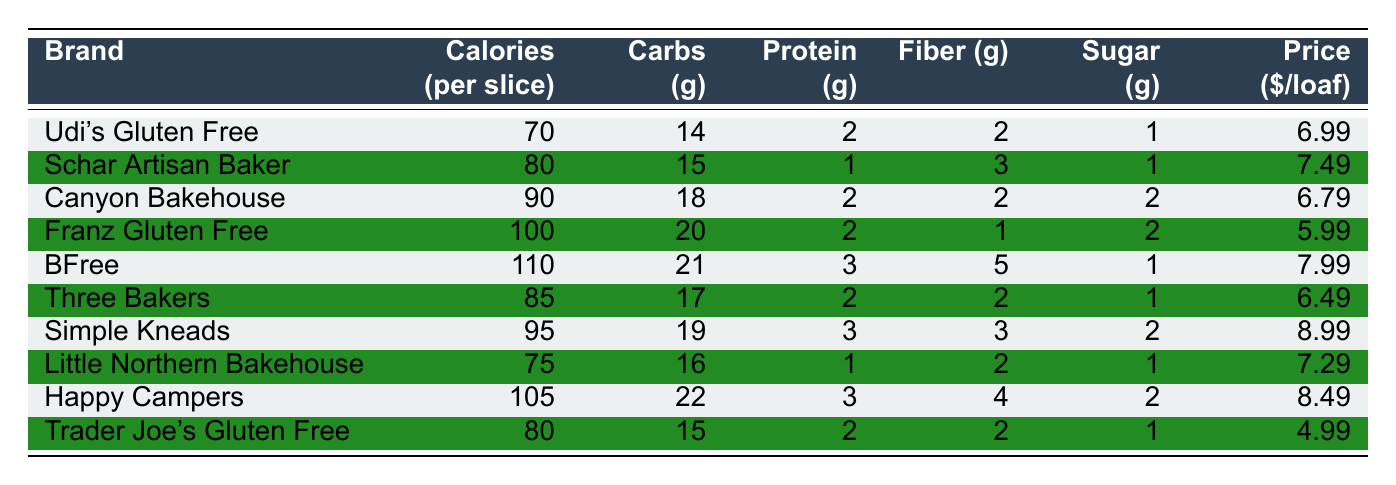What brand has the lowest calories per slice? By checking the "Calories (per slice)" column, Udi's Gluten Free has the lowest at 70 calories.
Answer: Udi's Gluten Free Which brand has the highest sugar content? Looking at the "Sugar (g)" column, Happy Campers has the highest with 2 grams of sugar.
Answer: Happy Campers What is the average price of the gluten-free bread brands listed? To find the average price, sum all prices ($6.99 + $7.49 + $6.79 + $5.99 + $7.99 + $6.49 + $8.99 + $7.29 + $8.49 + $4.99 = $69.49) and divide by 10, which gives $6.949.
Answer: $6.95 Is there a brand that has more protein than Canyon Bakehouse? Canyon Bakehouse has 2 grams of protein. BFree and Simple Kneads have 3 grams of protein, which is more than Canyon Bakehouse.
Answer: Yes Which brand's price is the lowest, and how much is it? Trader Joe's Gluten Free has the lowest price at $4.99.
Answer: $4.99 What is the total carbohydrate content of Udi's Gluten Free and Little Northern Bakehouse combined? Udi's Gluten Free has 14 grams of carbs, and Little Northern Bakehouse has 16 grams. Adding them together (14 + 16) gives a total of 30 grams.
Answer: 30 grams Which brand has the highest fiber content and what is that content? Checking the "Fiber (g)" column, BFree has the highest fiber content at 5 grams.
Answer: BFree, 5 grams How do the calories of Simple Kneads compare to those of Franz Gluten Free? Simple Kneads has 95 calories, whereas Franz Gluten Free has 100 calories. Thus, Simple Kneads has 5 fewer calories.
Answer: Simple Kneads has 5 fewer calories What is the difference in sugar content between the brand with the highest sugar and the one with the lowest? The highest sugar content is Happy Campers at 2 grams, while Udi's Gluten Free has 1 gram. The difference is 2 - 1 = 1 gram.
Answer: 1 gram Are there any brands with the same protein content as Trader Joe's Gluten Free? Trader Joe's Gluten Free has 2 grams of protein. Both Udi's Gluten Free and Canyon Bakehouse also have 2 grams of protein, so yes, there are other brands with the same content.
Answer: Yes 